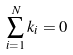<formula> <loc_0><loc_0><loc_500><loc_500>\sum _ { i = 1 } ^ { N } k _ { i } = 0</formula> 